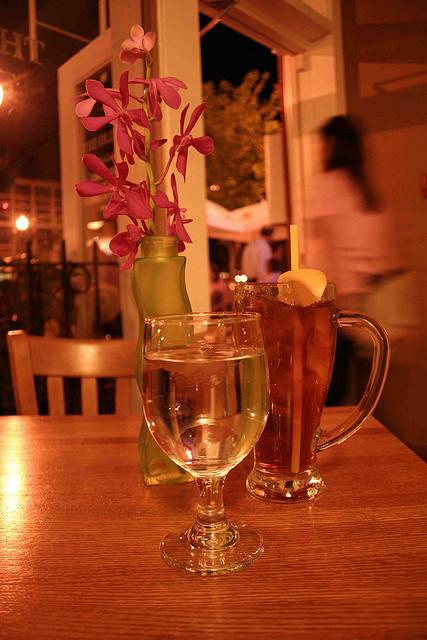What is in the pitcher?
Keep it brief. Tea. How many drinks are there?
Short answer required. 2. Is this at a home?
Be succinct. No. What is the beverage with a lemon?
Answer briefly. Tea. 